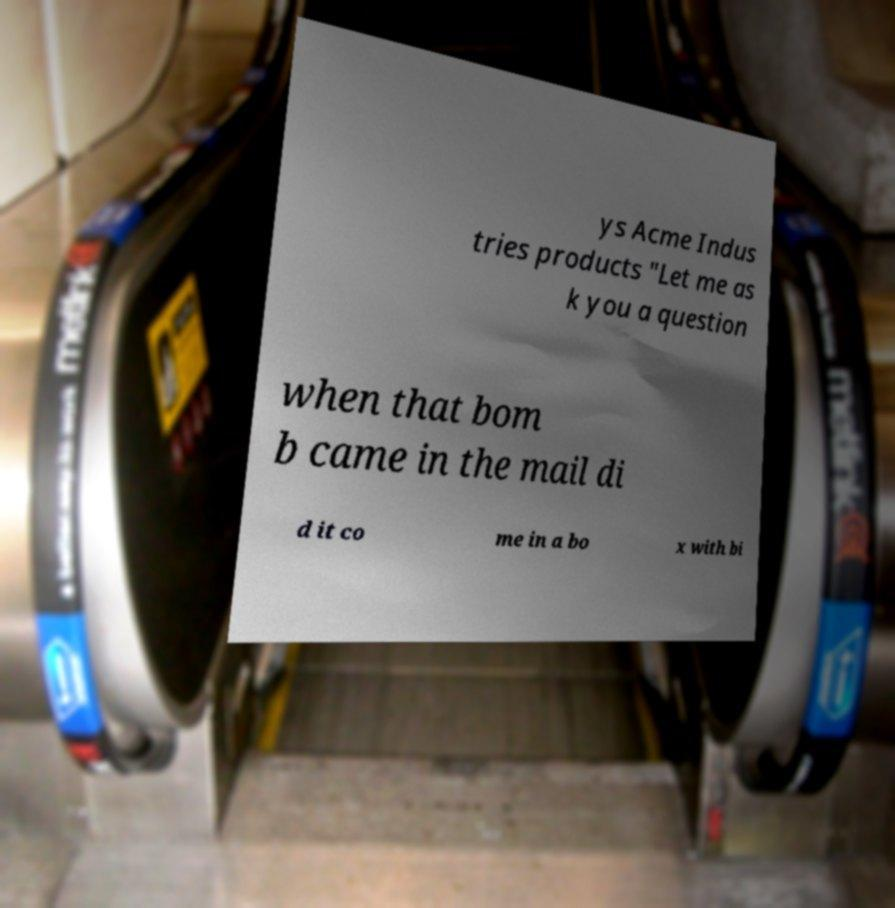Could you assist in decoding the text presented in this image and type it out clearly? ys Acme Indus tries products "Let me as k you a question when that bom b came in the mail di d it co me in a bo x with bi 